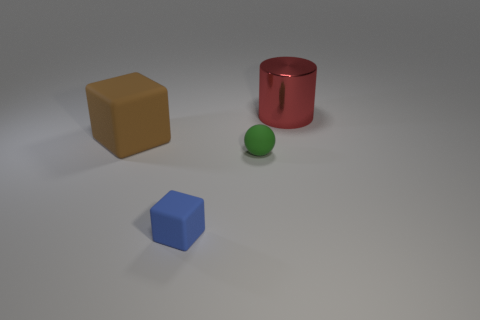There is a big object to the right of the big thing in front of the big red object; what is it made of? metal 